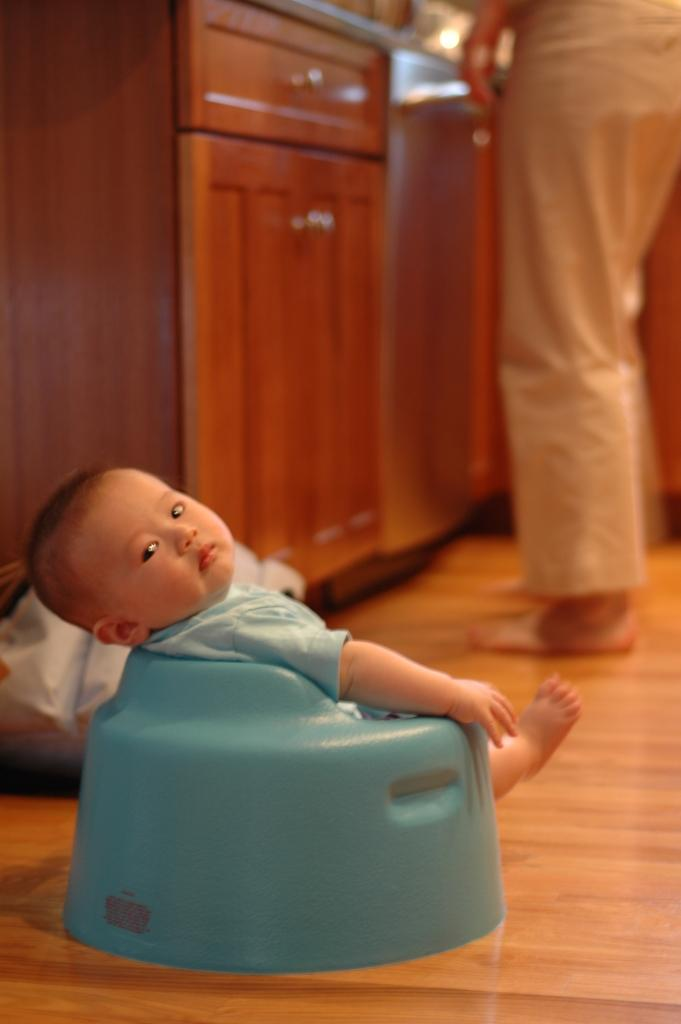What is the main subject of the image? The main subject of the image is a baby sitting on a seat. Can you describe the surroundings of the baby? On the right side of the image, there are legs of a person visible. What type of furniture is present in the image? There is a table with cupboards in the image. Reasoning: Let's think step by step by step in order to produce the conversation. We start by identifying the main subject of the image, which is the baby sitting on a seat. Then, we describe the surroundings of the baby, mentioning the legs of a person on the right side of the image. Finally, we expand the conversation to include the furniture present in the image, which is a table with cupboards. Absurd Question/Answer: What role does the baby's partner play in the image? There is no mention of a partner in the image, as it only features a baby sitting on a seat and a person's legs on the right side. Is there any indication of a war or conflict in the image? No, there is no indication of a war or conflict in the image; it is a simple scene featuring a baby and a person's legs. What type of hydrant is visible in the image? There is no hydrant present in the image; it only features a baby sitting on a seat, a person's legs on the right side, and a table with cupboards. 